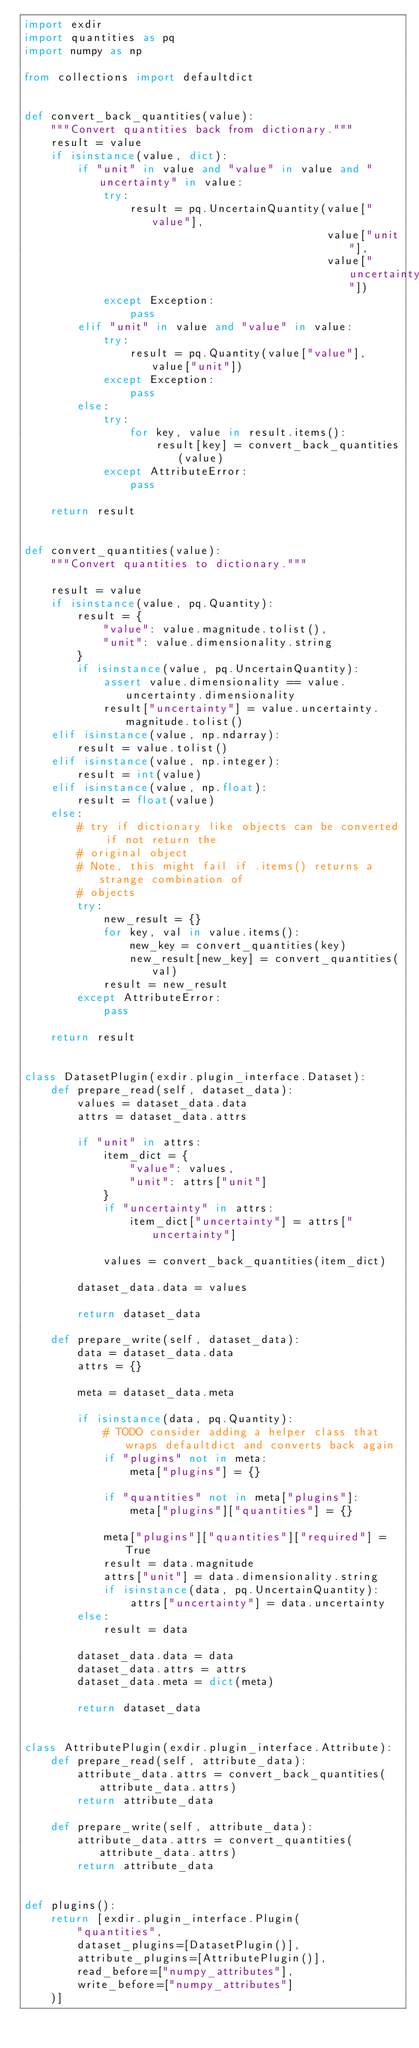Convert code to text. <code><loc_0><loc_0><loc_500><loc_500><_Python_>import exdir
import quantities as pq
import numpy as np

from collections import defaultdict


def convert_back_quantities(value):
    """Convert quantities back from dictionary."""
    result = value
    if isinstance(value, dict):
        if "unit" in value and "value" in value and "uncertainty" in value:
            try:
                result = pq.UncertainQuantity(value["value"],
                                              value["unit"],
                                              value["uncertainty"])
            except Exception:
                pass
        elif "unit" in value and "value" in value:
            try:
                result = pq.Quantity(value["value"], value["unit"])
            except Exception:
                pass
        else:
            try:
                for key, value in result.items():
                    result[key] = convert_back_quantities(value)
            except AttributeError:
                pass

    return result


def convert_quantities(value):
    """Convert quantities to dictionary."""

    result = value
    if isinstance(value, pq.Quantity):
        result = {
            "value": value.magnitude.tolist(),
            "unit": value.dimensionality.string
        }
        if isinstance(value, pq.UncertainQuantity):
            assert value.dimensionality == value.uncertainty.dimensionality
            result["uncertainty"] = value.uncertainty.magnitude.tolist()
    elif isinstance(value, np.ndarray):
        result = value.tolist()
    elif isinstance(value, np.integer):
        result = int(value)
    elif isinstance(value, np.float):
        result = float(value)
    else:
        # try if dictionary like objects can be converted if not return the
        # original object
        # Note, this might fail if .items() returns a strange combination of
        # objects
        try:
            new_result = {}
            for key, val in value.items():
                new_key = convert_quantities(key)
                new_result[new_key] = convert_quantities(val)
            result = new_result
        except AttributeError:
            pass

    return result


class DatasetPlugin(exdir.plugin_interface.Dataset):
    def prepare_read(self, dataset_data):
        values = dataset_data.data
        attrs = dataset_data.attrs

        if "unit" in attrs:
            item_dict = {
                "value": values,
                "unit": attrs["unit"]
            }
            if "uncertainty" in attrs:
                item_dict["uncertainty"] = attrs["uncertainty"]

            values = convert_back_quantities(item_dict)

        dataset_data.data = values

        return dataset_data

    def prepare_write(self, dataset_data):
        data = dataset_data.data
        attrs = {}

        meta = dataset_data.meta

        if isinstance(data, pq.Quantity):
            # TODO consider adding a helper class that wraps defaultdict and converts back again
            if "plugins" not in meta:
                meta["plugins"] = {}

            if "quantities" not in meta["plugins"]:
                meta["plugins"]["quantities"] = {}

            meta["plugins"]["quantities"]["required"] = True
            result = data.magnitude
            attrs["unit"] = data.dimensionality.string
            if isinstance(data, pq.UncertainQuantity):
                attrs["uncertainty"] = data.uncertainty
        else:
            result = data

        dataset_data.data = data
        dataset_data.attrs = attrs
        dataset_data.meta = dict(meta)

        return dataset_data


class AttributePlugin(exdir.plugin_interface.Attribute):
    def prepare_read(self, attribute_data):
        attribute_data.attrs = convert_back_quantities(attribute_data.attrs)
        return attribute_data

    def prepare_write(self, attribute_data):
        attribute_data.attrs = convert_quantities(attribute_data.attrs)
        return attribute_data


def plugins():
    return [exdir.plugin_interface.Plugin(
        "quantities",
        dataset_plugins=[DatasetPlugin()],
        attribute_plugins=[AttributePlugin()],
        read_before=["numpy_attributes"],
        write_before=["numpy_attributes"]
    )]
</code> 